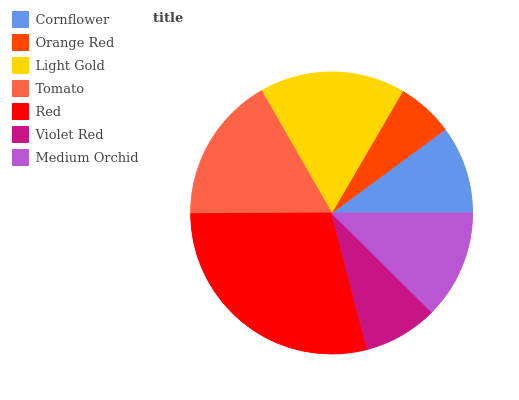Is Orange Red the minimum?
Answer yes or no. Yes. Is Red the maximum?
Answer yes or no. Yes. Is Light Gold the minimum?
Answer yes or no. No. Is Light Gold the maximum?
Answer yes or no. No. Is Light Gold greater than Orange Red?
Answer yes or no. Yes. Is Orange Red less than Light Gold?
Answer yes or no. Yes. Is Orange Red greater than Light Gold?
Answer yes or no. No. Is Light Gold less than Orange Red?
Answer yes or no. No. Is Medium Orchid the high median?
Answer yes or no. Yes. Is Medium Orchid the low median?
Answer yes or no. Yes. Is Cornflower the high median?
Answer yes or no. No. Is Cornflower the low median?
Answer yes or no. No. 